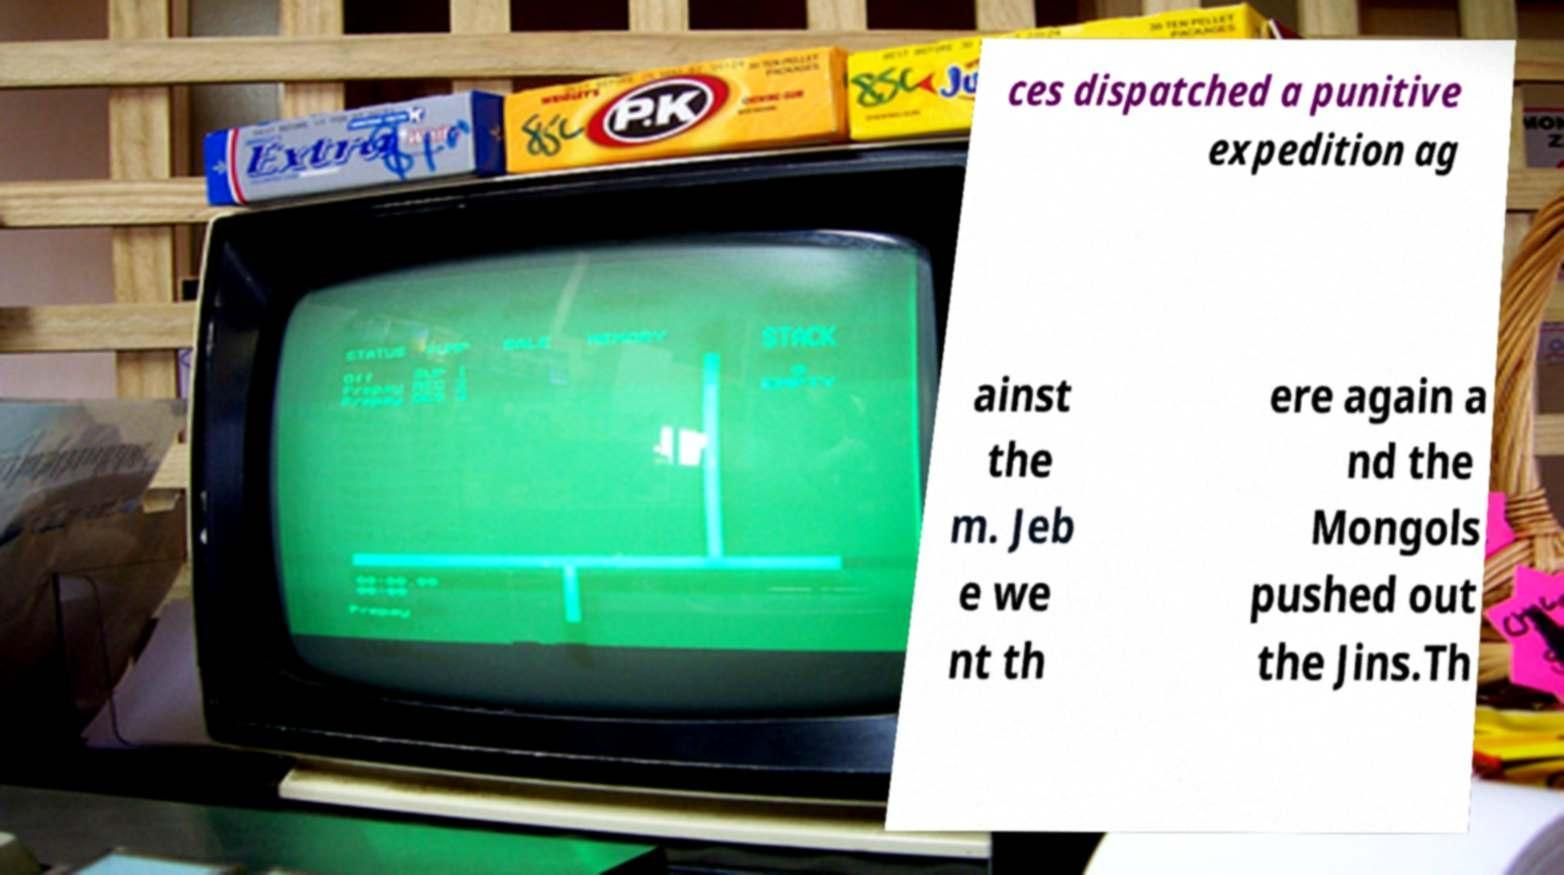Please read and relay the text visible in this image. What does it say? ces dispatched a punitive expedition ag ainst the m. Jeb e we nt th ere again a nd the Mongols pushed out the Jins.Th 